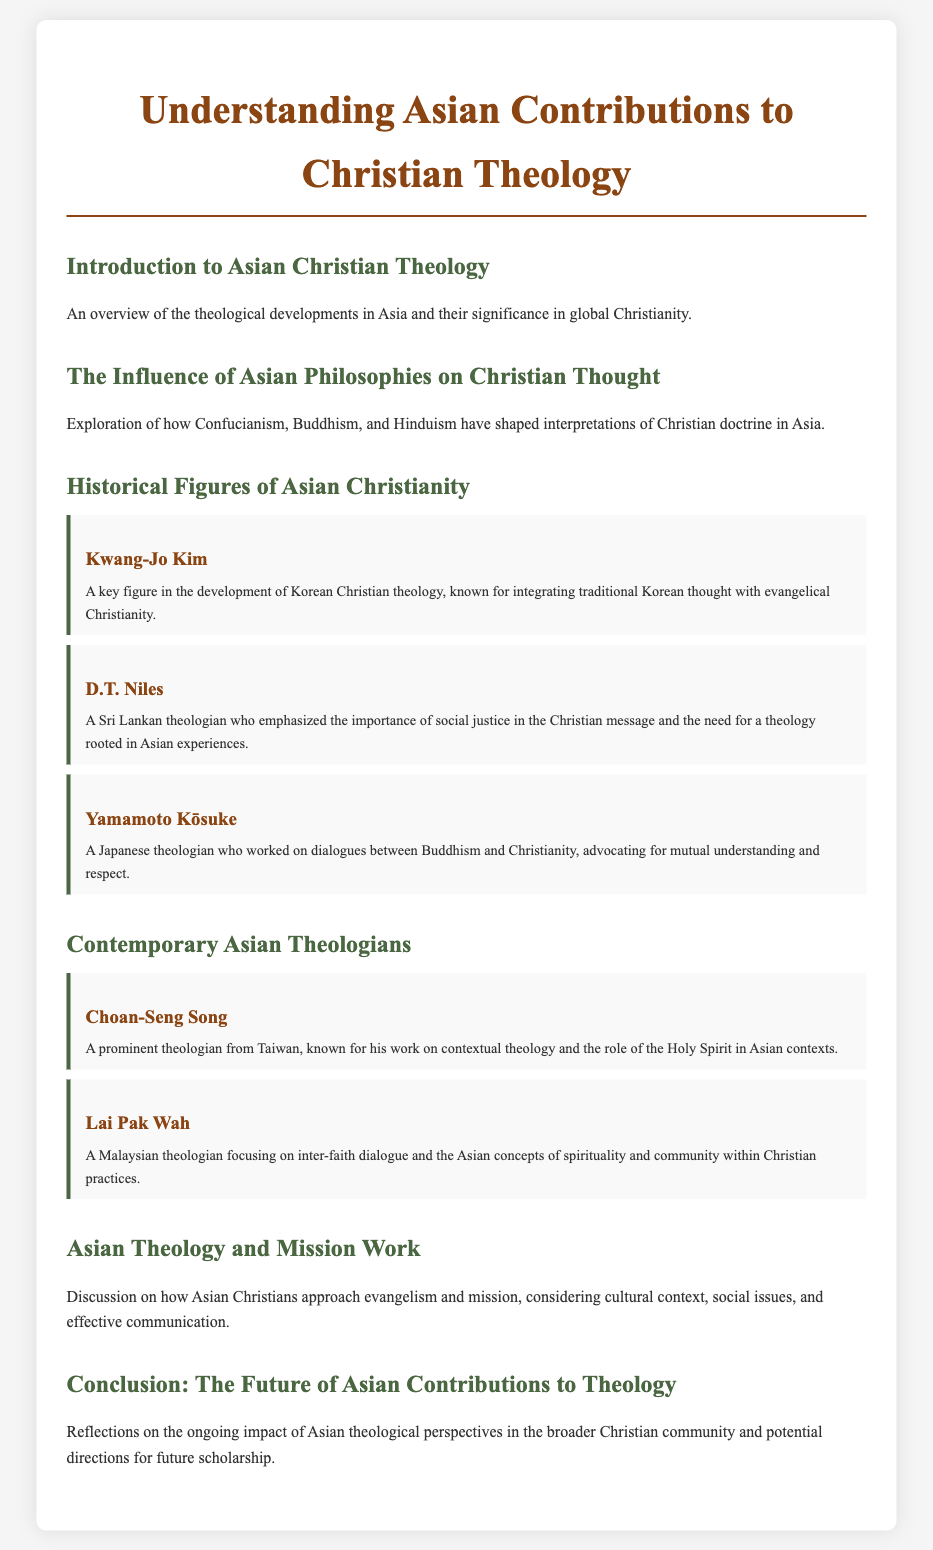what is the title of the document? The title provides the main focus of the document, which is presented prominently.
Answer: Understanding Asian Contributions to Christian Theology who is a key figure in the development of Korean Christian theology? The document lists several historical figures, highlighting their contributions.
Answer: Kwang-Jo Kim which theologian emphasized social justice in Christian messages? The document specifies a theologian known for his focus on social justice.
Answer: D.T. Niles what country is Choan-Seng Song from? The document provides the nationality of the contemporary theologian mentioned.
Answer: Taiwan what is the primary focus of Lai Pak Wah's theology? The menu details the main subject of this theologian's work.
Answer: inter-faith dialogue how many historical figures are listed in the document? The document includes a count of the significant personalities in Asian Christianity.
Answer: Three what aspect of theology is discussed in relation to Asian philosophies? The document highlights the influence of specific philosophies on doctrinal interpretations.
Answer: Christian thought what does the conclusion reflect on regarding Asian contributions? The document summarizes the impact of the discussed theological perspectives.
Answer: ongoing impact 